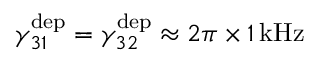Convert formula to latex. <formula><loc_0><loc_0><loc_500><loc_500>\gamma _ { 3 1 } ^ { d e p } = \gamma _ { 3 2 } ^ { d e p } \approx 2 \pi \times 1 \, k H z</formula> 